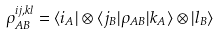<formula> <loc_0><loc_0><loc_500><loc_500>\rho _ { A B } ^ { i j , k l } = \langle i _ { A } | \otimes \langle j _ { B } | \rho _ { A B } | k _ { A } \rangle \otimes | l _ { B } \rangle</formula> 